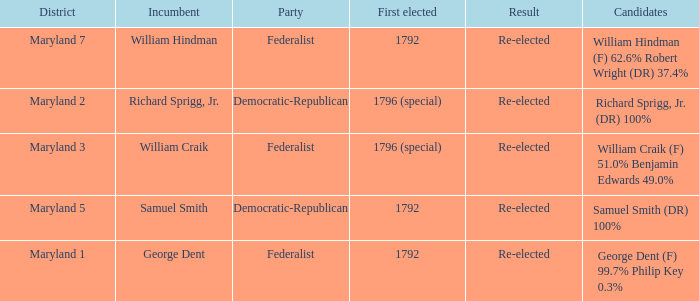What is the district for the party federalist and the candidates are william craik (f) 51.0% benjamin edwards 49.0%? Maryland 3. 